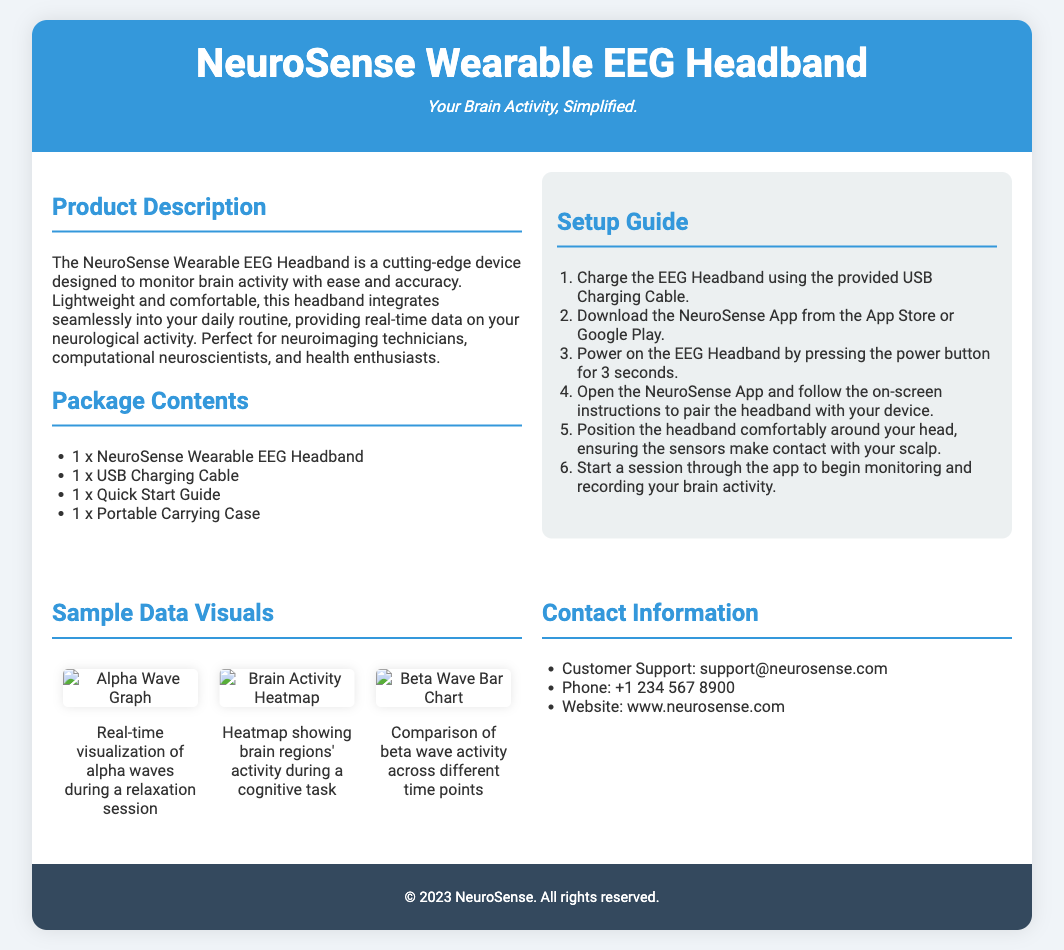What is the name of the product? The name of the product is given in the title and header of the document.
Answer: NeuroSense Wearable EEG Headband How many items are included in the package? The number of items is listed in the Package Contents section of the document.
Answer: 4 What type of cable is included with the headband? The type of cable is specified in the Package Contents section.
Answer: USB Charging Cable What are the first two steps in the Setup Guide? The first two steps are outlined in the order of the Setup Guide section.
Answer: Charge the EEG Headband, Download the NeuroSense App What should you do after positioning the headband? This action follows the guidelines set in the Setup Guide section and involves the next step after positioning.
Answer: Start a session through the app What is shown in the alpha wave graph? The content of the visual is described immediately under the image in the Sample Data Visuals section.
Answer: Real-time visualization of alpha waves during a relaxation session How can you contact customer support? The contact method is provided in the Contact Information section of the document.
Answer: support@neurosense.com What is the color of the header background? The color of the header is specified in the stylesheet of the document.
Answer: #3498db 